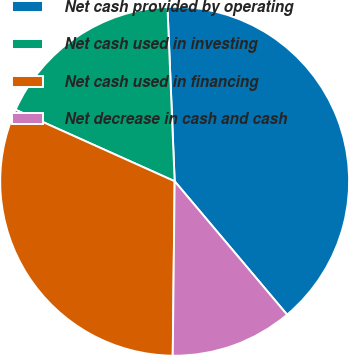Convert chart to OTSL. <chart><loc_0><loc_0><loc_500><loc_500><pie_chart><fcel>Net cash provided by operating<fcel>Net cash used in investing<fcel>Net cash used in financing<fcel>Net decrease in cash and cash<nl><fcel>39.51%<fcel>17.62%<fcel>31.55%<fcel>11.32%<nl></chart> 